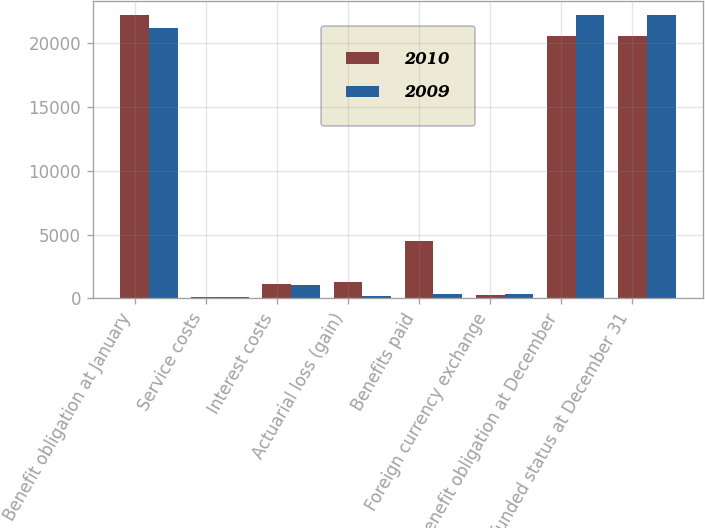<chart> <loc_0><loc_0><loc_500><loc_500><stacked_bar_chart><ecel><fcel>Benefit obligation at January<fcel>Service costs<fcel>Interest costs<fcel>Actuarial loss (gain)<fcel>Benefits paid<fcel>Foreign currency exchange<fcel>Benefit obligation at December<fcel>Unfunded status at December 31<nl><fcel>2010<fcel>22220<fcel>142<fcel>1135<fcel>1319<fcel>4541<fcel>289<fcel>20564<fcel>20564<nl><fcel>2009<fcel>21237<fcel>125<fcel>1085<fcel>219<fcel>353<fcel>345<fcel>22220<fcel>22220<nl></chart> 